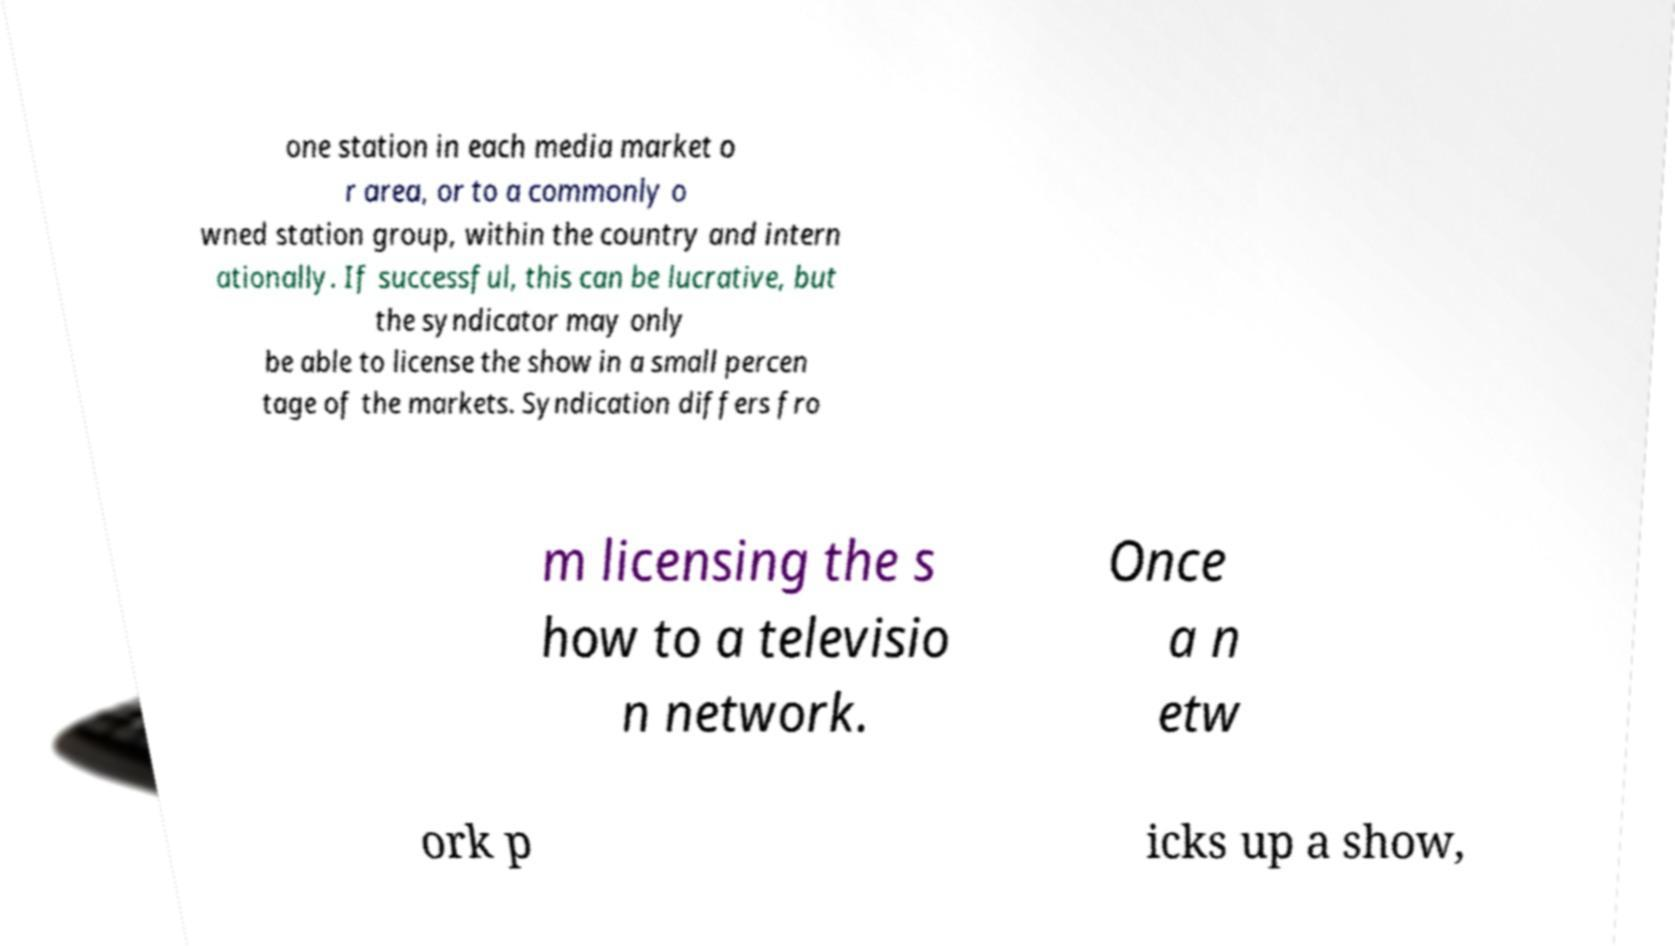I need the written content from this picture converted into text. Can you do that? one station in each media market o r area, or to a commonly o wned station group, within the country and intern ationally. If successful, this can be lucrative, but the syndicator may only be able to license the show in a small percen tage of the markets. Syndication differs fro m licensing the s how to a televisio n network. Once a n etw ork p icks up a show, 